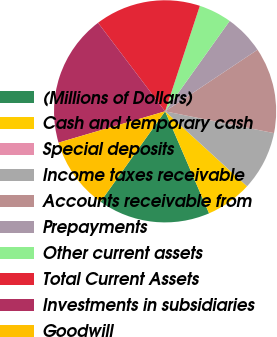Convert chart to OTSL. <chart><loc_0><loc_0><loc_500><loc_500><pie_chart><fcel>(Millions of Dollars)<fcel>Cash and temporary cash<fcel>Special deposits<fcel>Income taxes receivable<fcel>Accounts receivable from<fcel>Prepayments<fcel>Other current assets<fcel>Total Current Assets<fcel>Investments in subsidiaries<fcel>Goodwill<nl><fcel>16.35%<fcel>6.73%<fcel>0.0%<fcel>8.65%<fcel>12.5%<fcel>5.77%<fcel>4.81%<fcel>15.38%<fcel>19.23%<fcel>10.58%<nl></chart> 